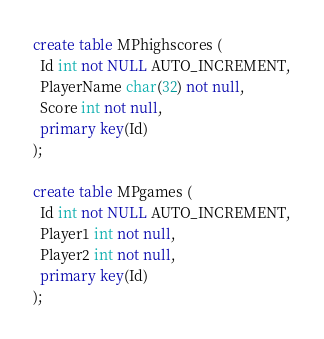Convert code to text. <code><loc_0><loc_0><loc_500><loc_500><_SQL_>create table MPhighscores (
  Id int not NULL AUTO_INCREMENT,
  PlayerName char(32) not null,
  Score int not null,
  primary key(Id)
);

create table MPgames (
  Id int not NULL AUTO_INCREMENT,
  Player1 int not null,
  Player2 int not null,
  primary key(Id)
);</code> 